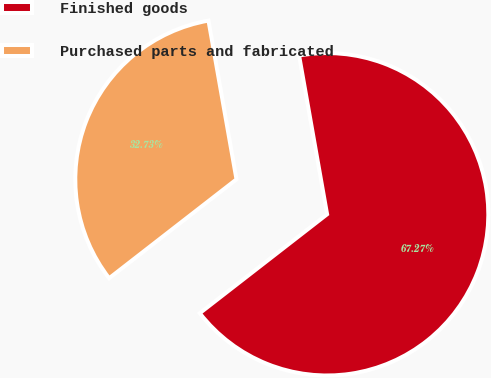<chart> <loc_0><loc_0><loc_500><loc_500><pie_chart><fcel>Finished goods<fcel>Purchased parts and fabricated<nl><fcel>67.27%<fcel>32.73%<nl></chart> 